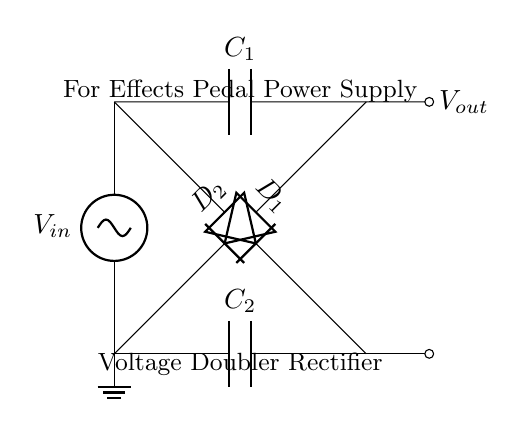What type of rectifier is illustrated in the circuit? The circuit is a voltage doubler rectifier, which is indicated by the configuration of the diodes and capacitors specifically arranged to boost the voltage output.
Answer: voltage doubler rectifier What is the main function of the capacitors in this circuit? The capacitors, C1 and C2, serve to store electrical energy and smooth out the output voltage, helping to stabilize the power supply for the effects pedal.
Answer: smooth output voltage How many diodes are present in the circuit? The circuit contains two diodes, D1 and D2, which are used in conjunction with the capacitors to perform the rectification process.
Answer: two What is the output voltage in relation to the input voltage? The output voltage is approximately double the input voltage due to the voltage doubling configuration of the rectifier circuit.
Answer: double Which components are used for the rectification process? The diodes D1 and D2, along with the capacitors C1 and C2, work together to convert the alternating current input into a higher direct current output.
Answer: diodes D1 and D2 How do the diodes affect the current flow in this circuit? The diodes allow current to flow in only one direction, which is crucial for converting alternating current to direct current while preventing reverse current that could damage the components.
Answer: allow current in one direction What practical application is this voltage doubler rectifier circuit designed for? The circuit is designed specifically for effects pedal power supply, indicating its use in audio applications for boosting power while providing stable voltage.
Answer: effects pedal power supply 